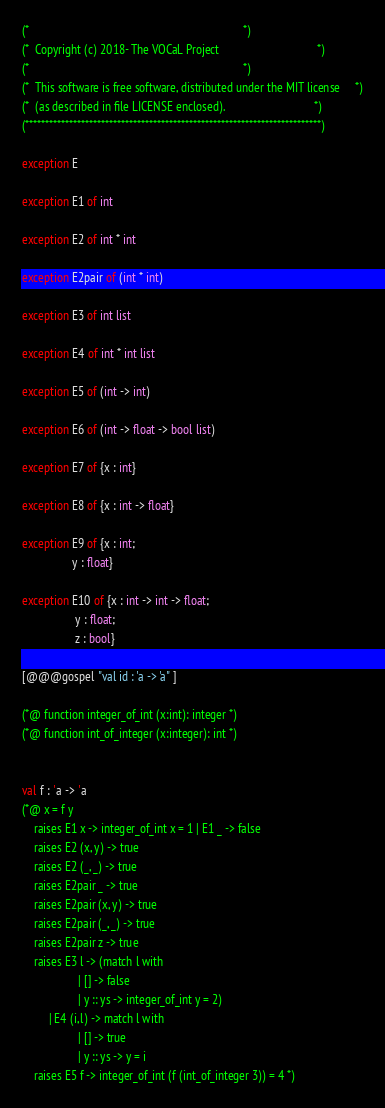Convert code to text. <code><loc_0><loc_0><loc_500><loc_500><_OCaml_>(*                                                                        *)
(*  Copyright (c) 2018- The VOCaL Project                                 *)
(*                                                                        *)
(*  This software is free software, distributed under the MIT license     *)
(*  (as described in file LICENSE enclosed).                              *)
(**************************************************************************)

exception E

exception E1 of int

exception E2 of int * int

exception E2pair of (int * int)

exception E3 of int list

exception E4 of int * int list

exception E5 of (int -> int)

exception E6 of (int -> float -> bool list)

exception E7 of {x : int}

exception E8 of {x : int -> float}

exception E9 of {x : int;
                 y : float}

exception E10 of {x : int -> int -> float;
                  y : float;
                  z : bool}

[@@@gospel "val id : 'a -> 'a" ]

(*@ function integer_of_int (x:int): integer *)
(*@ function int_of_integer (x:integer): int *)


val f : 'a -> 'a
(*@ x = f y
    raises E1 x -> integer_of_int x = 1 | E1 _ -> false
    raises E2 (x, y) -> true
    raises E2 (_, _) -> true
    raises E2pair _ -> true
    raises E2pair (x, y) -> true
    raises E2pair (_, _) -> true
    raises E2pair z -> true
    raises E3 l -> (match l with
                   | [] -> false
                   | y :: ys -> integer_of_int y = 2)
         | E4 (i,l) -> match l with
                   | [] -> true
                   | y :: ys -> y = i
    raises E5 f -> integer_of_int (f (int_of_integer 3)) = 4 *)
</code> 